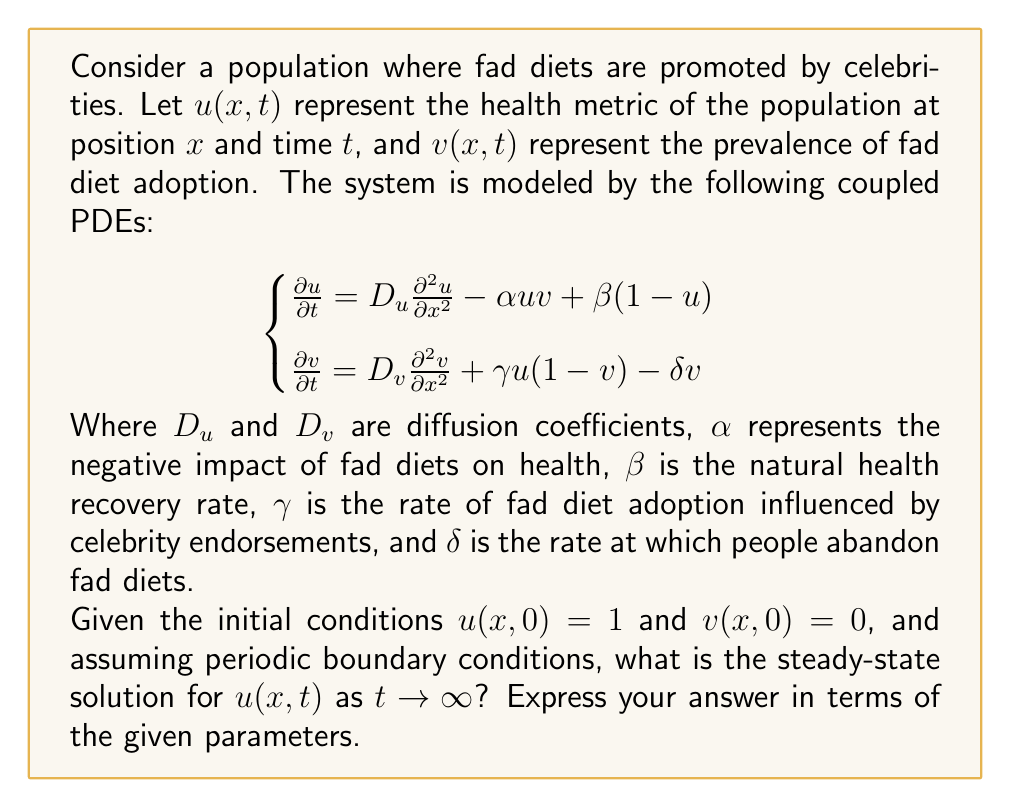Solve this math problem. To find the steady-state solution, we follow these steps:

1) In steady-state, the time derivatives become zero:
   $$\begin{cases}
   0 = D_u \frac{\partial^2 u}{\partial x^2} - \alpha uv + \beta(1-u) \\
   0 = D_v \frac{\partial^2 v}{\partial x^2} + \gamma u(1-v) - \delta v
   \end{cases}$$

2) For a homogeneous steady-state, spatial derivatives are also zero:
   $$\begin{cases}
   0 = - \alpha uv + \beta(1-u) \\
   0 = \gamma u(1-v) - \delta v
   \end{cases}$$

3) From the second equation:
   $\gamma u(1-v) = \delta v$
   $\gamma u - \gamma uv = \delta v$
   $\gamma u = \delta v + \gamma uv$
   $\gamma u = v(\delta + \gamma u)$
   $v = \frac{\gamma u}{\delta + \gamma u}$

4) Substitute this into the first equation:
   $0 = - \alpha u(\frac{\gamma u}{\delta + \gamma u}) + \beta(1-u)$

5) Multiply both sides by $(\delta + \gamma u)$:
   $0 = - \alpha \gamma u^2 + \beta(1-u)(\delta + \gamma u)$

6) Expand:
   $0 = - \alpha \gamma u^2 + \beta \delta + \beta \gamma u - \beta \delta u - \beta \gamma u^2$

7) Rearrange:
   $(\alpha \gamma + \beta \gamma)u^2 + (\beta \delta - \beta \gamma)u - \beta \delta = 0$

8) This is a quadratic equation in $u$. Let $A = \alpha \gamma + \beta \gamma$, $B = \beta \delta - \beta \gamma$, and $C = -\beta \delta$. The solution is given by the quadratic formula:

   $u = \frac{-B \pm \sqrt{B^2 - 4AC}}{2A}$

9) Substitute back the values of $A$, $B$, and $C$:

   $u = \frac{-(\beta \delta - \beta \gamma) \pm \sqrt{(\beta \delta - \beta \gamma)^2 + 4(\alpha \gamma + \beta \gamma)(\beta \delta)}}{2(\alpha \gamma + \beta \gamma)}$

This is the steady-state solution for $u$ as $t \to \infty$.
Answer: $u = \frac{-(\beta \delta - \beta \gamma) \pm \sqrt{(\beta \delta - \beta \gamma)^2 + 4(\alpha \gamma + \beta \gamma)(\beta \delta)}}{2(\alpha \gamma + \beta \gamma)}$ 